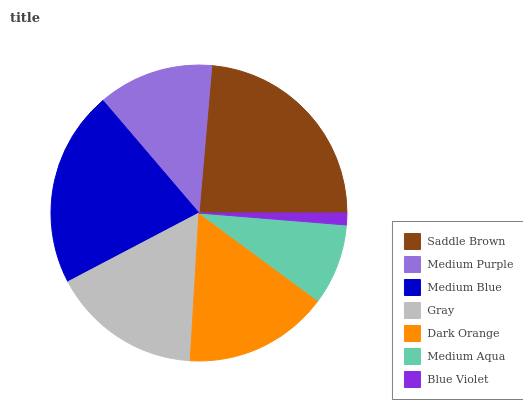Is Blue Violet the minimum?
Answer yes or no. Yes. Is Saddle Brown the maximum?
Answer yes or no. Yes. Is Medium Purple the minimum?
Answer yes or no. No. Is Medium Purple the maximum?
Answer yes or no. No. Is Saddle Brown greater than Medium Purple?
Answer yes or no. Yes. Is Medium Purple less than Saddle Brown?
Answer yes or no. Yes. Is Medium Purple greater than Saddle Brown?
Answer yes or no. No. Is Saddle Brown less than Medium Purple?
Answer yes or no. No. Is Dark Orange the high median?
Answer yes or no. Yes. Is Dark Orange the low median?
Answer yes or no. Yes. Is Saddle Brown the high median?
Answer yes or no. No. Is Blue Violet the low median?
Answer yes or no. No. 